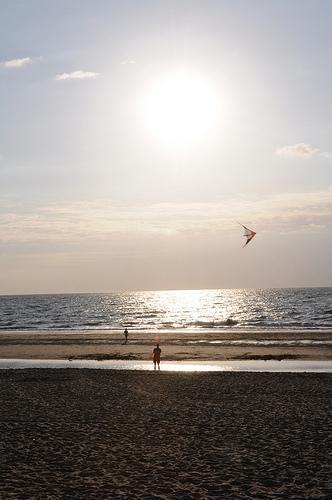How many people are there here?
Give a very brief answer. 2. 